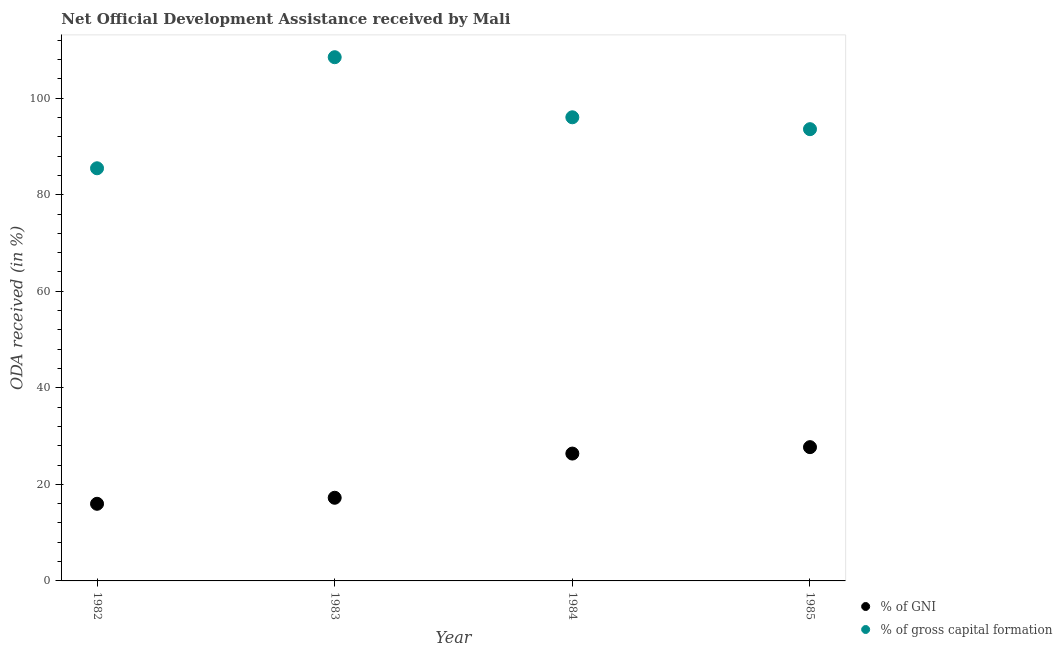How many different coloured dotlines are there?
Your answer should be very brief. 2. Is the number of dotlines equal to the number of legend labels?
Offer a terse response. Yes. What is the oda received as percentage of gni in 1983?
Provide a short and direct response. 17.23. Across all years, what is the maximum oda received as percentage of gni?
Give a very brief answer. 27.71. Across all years, what is the minimum oda received as percentage of gni?
Give a very brief answer. 15.98. In which year was the oda received as percentage of gross capital formation maximum?
Provide a succinct answer. 1983. What is the total oda received as percentage of gross capital formation in the graph?
Your response must be concise. 383.62. What is the difference between the oda received as percentage of gross capital formation in 1984 and that in 1985?
Your response must be concise. 2.46. What is the difference between the oda received as percentage of gni in 1985 and the oda received as percentage of gross capital formation in 1984?
Provide a succinct answer. -68.33. What is the average oda received as percentage of gross capital formation per year?
Provide a succinct answer. 95.9. In the year 1985, what is the difference between the oda received as percentage of gni and oda received as percentage of gross capital formation?
Your answer should be very brief. -65.87. In how many years, is the oda received as percentage of gni greater than 52 %?
Provide a short and direct response. 0. What is the ratio of the oda received as percentage of gross capital formation in 1982 to that in 1985?
Ensure brevity in your answer.  0.91. Is the oda received as percentage of gross capital formation in 1982 less than that in 1985?
Keep it short and to the point. Yes. What is the difference between the highest and the second highest oda received as percentage of gross capital formation?
Keep it short and to the point. 12.45. What is the difference between the highest and the lowest oda received as percentage of gross capital formation?
Your answer should be very brief. 23.01. Is the sum of the oda received as percentage of gross capital formation in 1983 and 1984 greater than the maximum oda received as percentage of gni across all years?
Offer a very short reply. Yes. Is the oda received as percentage of gross capital formation strictly greater than the oda received as percentage of gni over the years?
Keep it short and to the point. Yes. What is the difference between two consecutive major ticks on the Y-axis?
Your answer should be very brief. 20. Are the values on the major ticks of Y-axis written in scientific E-notation?
Keep it short and to the point. No. Does the graph contain any zero values?
Provide a succinct answer. No. Does the graph contain grids?
Give a very brief answer. No. Where does the legend appear in the graph?
Offer a terse response. Bottom right. What is the title of the graph?
Offer a very short reply. Net Official Development Assistance received by Mali. What is the label or title of the Y-axis?
Make the answer very short. ODA received (in %). What is the ODA received (in %) in % of GNI in 1982?
Provide a short and direct response. 15.98. What is the ODA received (in %) in % of gross capital formation in 1982?
Ensure brevity in your answer.  85.49. What is the ODA received (in %) of % of GNI in 1983?
Give a very brief answer. 17.23. What is the ODA received (in %) in % of gross capital formation in 1983?
Your answer should be compact. 108.5. What is the ODA received (in %) in % of GNI in 1984?
Make the answer very short. 26.38. What is the ODA received (in %) in % of gross capital formation in 1984?
Your response must be concise. 96.05. What is the ODA received (in %) in % of GNI in 1985?
Keep it short and to the point. 27.71. What is the ODA received (in %) of % of gross capital formation in 1985?
Offer a very short reply. 93.59. Across all years, what is the maximum ODA received (in %) in % of GNI?
Your response must be concise. 27.71. Across all years, what is the maximum ODA received (in %) in % of gross capital formation?
Provide a short and direct response. 108.5. Across all years, what is the minimum ODA received (in %) of % of GNI?
Your response must be concise. 15.98. Across all years, what is the minimum ODA received (in %) in % of gross capital formation?
Your response must be concise. 85.49. What is the total ODA received (in %) in % of GNI in the graph?
Your response must be concise. 87.3. What is the total ODA received (in %) in % of gross capital formation in the graph?
Provide a short and direct response. 383.62. What is the difference between the ODA received (in %) of % of GNI in 1982 and that in 1983?
Make the answer very short. -1.25. What is the difference between the ODA received (in %) in % of gross capital formation in 1982 and that in 1983?
Your answer should be very brief. -23.01. What is the difference between the ODA received (in %) in % of GNI in 1982 and that in 1984?
Offer a very short reply. -10.4. What is the difference between the ODA received (in %) of % of gross capital formation in 1982 and that in 1984?
Provide a succinct answer. -10.56. What is the difference between the ODA received (in %) of % of GNI in 1982 and that in 1985?
Give a very brief answer. -11.74. What is the difference between the ODA received (in %) in % of gross capital formation in 1982 and that in 1985?
Provide a short and direct response. -8.1. What is the difference between the ODA received (in %) in % of GNI in 1983 and that in 1984?
Offer a very short reply. -9.16. What is the difference between the ODA received (in %) of % of gross capital formation in 1983 and that in 1984?
Keep it short and to the point. 12.45. What is the difference between the ODA received (in %) of % of GNI in 1983 and that in 1985?
Offer a very short reply. -10.49. What is the difference between the ODA received (in %) in % of gross capital formation in 1983 and that in 1985?
Your response must be concise. 14.91. What is the difference between the ODA received (in %) in % of GNI in 1984 and that in 1985?
Ensure brevity in your answer.  -1.33. What is the difference between the ODA received (in %) in % of gross capital formation in 1984 and that in 1985?
Your response must be concise. 2.46. What is the difference between the ODA received (in %) of % of GNI in 1982 and the ODA received (in %) of % of gross capital formation in 1983?
Offer a very short reply. -92.52. What is the difference between the ODA received (in %) of % of GNI in 1982 and the ODA received (in %) of % of gross capital formation in 1984?
Keep it short and to the point. -80.07. What is the difference between the ODA received (in %) in % of GNI in 1982 and the ODA received (in %) in % of gross capital formation in 1985?
Your response must be concise. -77.61. What is the difference between the ODA received (in %) of % of GNI in 1983 and the ODA received (in %) of % of gross capital formation in 1984?
Ensure brevity in your answer.  -78.82. What is the difference between the ODA received (in %) of % of GNI in 1983 and the ODA received (in %) of % of gross capital formation in 1985?
Provide a succinct answer. -76.36. What is the difference between the ODA received (in %) of % of GNI in 1984 and the ODA received (in %) of % of gross capital formation in 1985?
Ensure brevity in your answer.  -67.2. What is the average ODA received (in %) of % of GNI per year?
Give a very brief answer. 21.83. What is the average ODA received (in %) of % of gross capital formation per year?
Your answer should be very brief. 95.9. In the year 1982, what is the difference between the ODA received (in %) in % of GNI and ODA received (in %) in % of gross capital formation?
Provide a short and direct response. -69.51. In the year 1983, what is the difference between the ODA received (in %) of % of GNI and ODA received (in %) of % of gross capital formation?
Keep it short and to the point. -91.27. In the year 1984, what is the difference between the ODA received (in %) of % of GNI and ODA received (in %) of % of gross capital formation?
Your answer should be very brief. -69.67. In the year 1985, what is the difference between the ODA received (in %) in % of GNI and ODA received (in %) in % of gross capital formation?
Your answer should be very brief. -65.87. What is the ratio of the ODA received (in %) in % of GNI in 1982 to that in 1983?
Offer a very short reply. 0.93. What is the ratio of the ODA received (in %) in % of gross capital formation in 1982 to that in 1983?
Ensure brevity in your answer.  0.79. What is the ratio of the ODA received (in %) in % of GNI in 1982 to that in 1984?
Ensure brevity in your answer.  0.61. What is the ratio of the ODA received (in %) of % of gross capital formation in 1982 to that in 1984?
Your response must be concise. 0.89. What is the ratio of the ODA received (in %) in % of GNI in 1982 to that in 1985?
Provide a succinct answer. 0.58. What is the ratio of the ODA received (in %) in % of gross capital formation in 1982 to that in 1985?
Make the answer very short. 0.91. What is the ratio of the ODA received (in %) in % of GNI in 1983 to that in 1984?
Your answer should be very brief. 0.65. What is the ratio of the ODA received (in %) of % of gross capital formation in 1983 to that in 1984?
Provide a short and direct response. 1.13. What is the ratio of the ODA received (in %) in % of GNI in 1983 to that in 1985?
Give a very brief answer. 0.62. What is the ratio of the ODA received (in %) of % of gross capital formation in 1983 to that in 1985?
Offer a very short reply. 1.16. What is the ratio of the ODA received (in %) of % of GNI in 1984 to that in 1985?
Keep it short and to the point. 0.95. What is the ratio of the ODA received (in %) of % of gross capital formation in 1984 to that in 1985?
Provide a short and direct response. 1.03. What is the difference between the highest and the second highest ODA received (in %) in % of GNI?
Give a very brief answer. 1.33. What is the difference between the highest and the second highest ODA received (in %) of % of gross capital formation?
Your answer should be very brief. 12.45. What is the difference between the highest and the lowest ODA received (in %) in % of GNI?
Your response must be concise. 11.74. What is the difference between the highest and the lowest ODA received (in %) of % of gross capital formation?
Your answer should be compact. 23.01. 